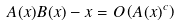Convert formula to latex. <formula><loc_0><loc_0><loc_500><loc_500>A ( x ) B ( x ) - x = O \left ( A ( x ) ^ { c } \right )</formula> 